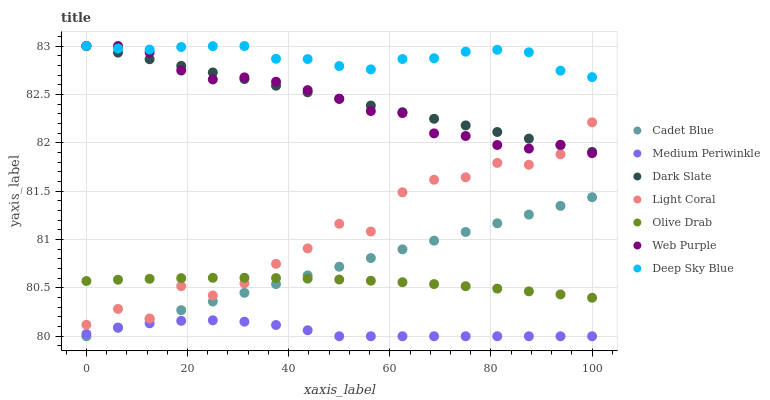Does Medium Periwinkle have the minimum area under the curve?
Answer yes or no. Yes. Does Deep Sky Blue have the maximum area under the curve?
Answer yes or no. Yes. Does Light Coral have the minimum area under the curve?
Answer yes or no. No. Does Light Coral have the maximum area under the curve?
Answer yes or no. No. Is Cadet Blue the smoothest?
Answer yes or no. Yes. Is Light Coral the roughest?
Answer yes or no. Yes. Is Medium Periwinkle the smoothest?
Answer yes or no. No. Is Medium Periwinkle the roughest?
Answer yes or no. No. Does Cadet Blue have the lowest value?
Answer yes or no. Yes. Does Light Coral have the lowest value?
Answer yes or no. No. Does Deep Sky Blue have the highest value?
Answer yes or no. Yes. Does Light Coral have the highest value?
Answer yes or no. No. Is Cadet Blue less than Web Purple?
Answer yes or no. Yes. Is Deep Sky Blue greater than Medium Periwinkle?
Answer yes or no. Yes. Does Dark Slate intersect Web Purple?
Answer yes or no. Yes. Is Dark Slate less than Web Purple?
Answer yes or no. No. Is Dark Slate greater than Web Purple?
Answer yes or no. No. Does Cadet Blue intersect Web Purple?
Answer yes or no. No. 